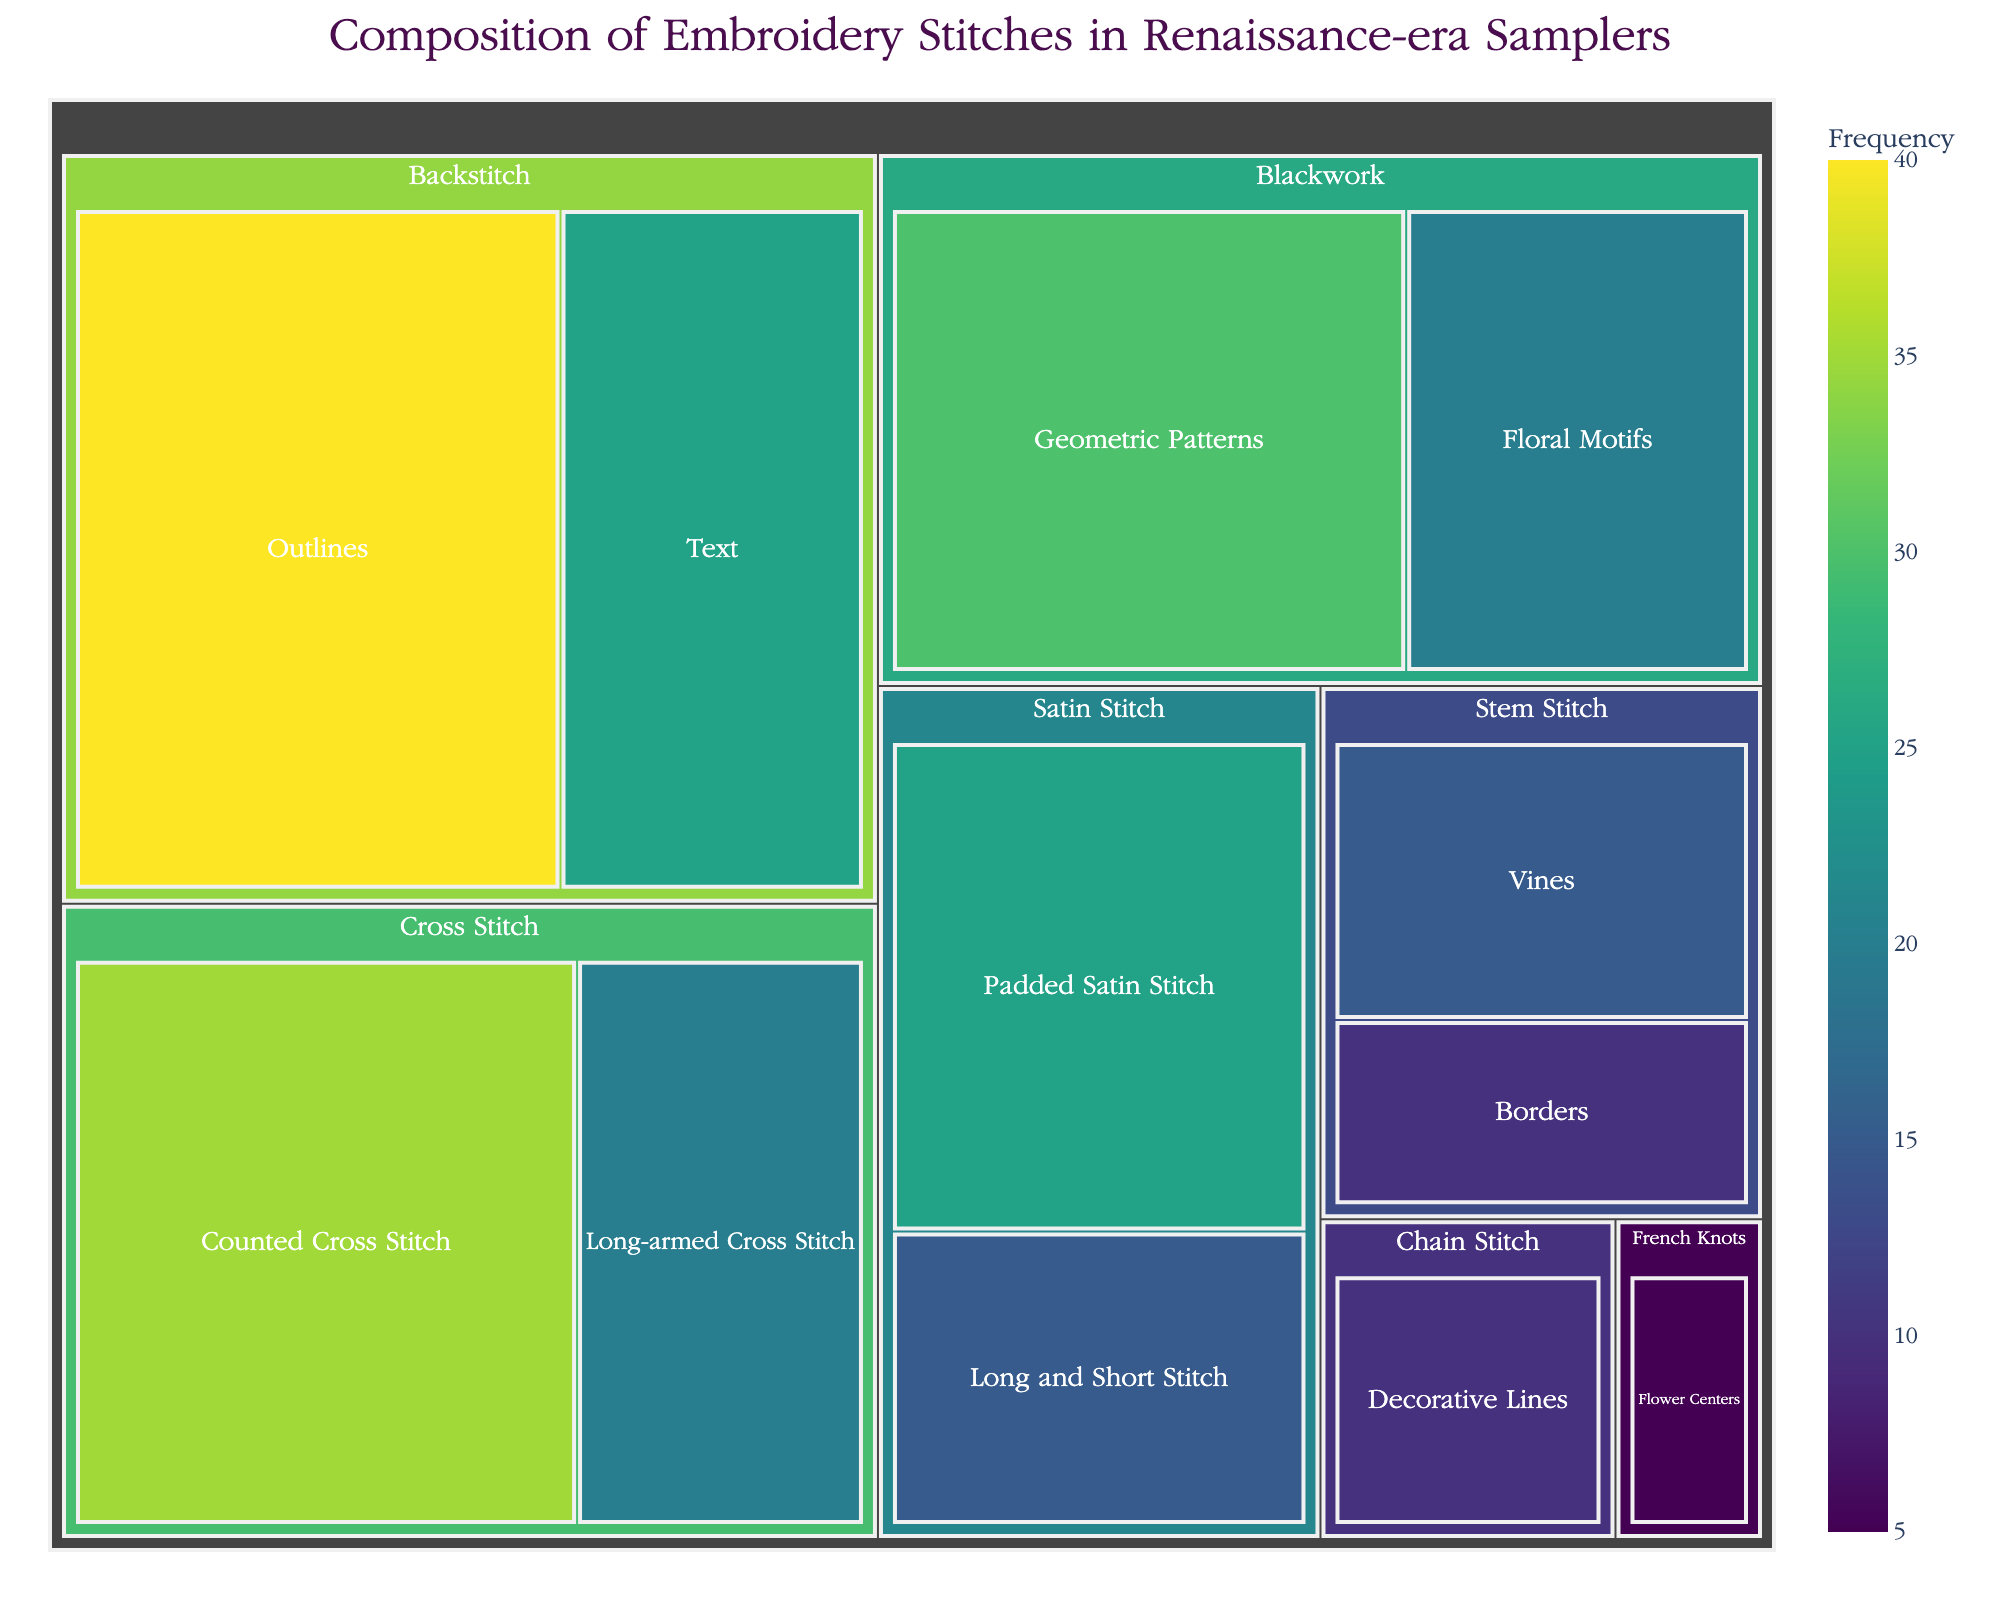Which category has the most frequent stitch in the Renaissance-era samplers? By looking at the treemap, the Backstitch category has the largest area, indicating it has the highest frequency stitches. Specifically, the "Outlines" subcategory has a value of 40, which is the highest among all subcategories.
Answer: Backstitch How many subcategories belong to the Cross Stitch category and what are their values? The Cross Stitch category includes two subcategories. The "Counted Cross Stitch" has a value of 35, and the "Long-armed Cross Stitch" has a value of 20.
Answer: 2 subcategories; 35 and 20 What is the total value of all subcategories under the Satin Stitch category? The two subcategories under Satin Stitch are "Padded Satin Stitch" worth 25 and "Long and Short Stitch" worth 15. Adding these gives 25 + 15 = 40.
Answer: 40 Which categories have subcategories with a value of 30 or higher? By checking the values, the categories with subcategories having values of 30 or higher are Backstitch (with "Outlines" having 40) and Blackwork (with "Geometric Patterns" having 30).
Answer: Backstitch and Blackwork Between Chain Stitch and French Knots, which has a higher value and by how much? Chain Stitch has a "Decorative Lines" subcategory with a value of 10 while French Knots' "Flower Centers" has a value of 5. The difference is 10 - 5 = 5.
Answer: Chain Stitch by 5 What’s the frequency of the least represented subcategory in the plot? The subcategory with the smallest frequency is the "Flower Centers" under French Knots, which has a value of 5.
Answer: 5 Which subcategory represents the floral motifs and what is its value? The floral motifs are represented under the Blackwork category with the subcategory "Floral Motifs" having a value of 20.
Answer: Floral Motifs, 20 How does the sum of subcategory values under the Blackwork category compare to the sum of subcategory values under the Stem Stitch category? Blackwork's subcategories total 50 (Geometric Patterns: 30 + Floral Motifs: 20). Stem Stitch totals 25 (Vines: 15 + Borders: 10). 50 - 25 = 25 more in Blackwork.
Answer: Blackwork has 25 more Which subcategory in the tree map is centrally located and has the value of 35? The centrally located subcategory with a value of 35 is "Counted Cross Stitch" under the Cross Stitch category.
Answer: Counted Cross Stitch What category appears most diverse in terms of subcategories, and how many does it have? The category with the most diverse subcategories is Backstitch, which includes two subcategories: "Outlines" with 40 and "Text" with 25, totaling 2 subcategories.
Answer: Backstitch, 2 